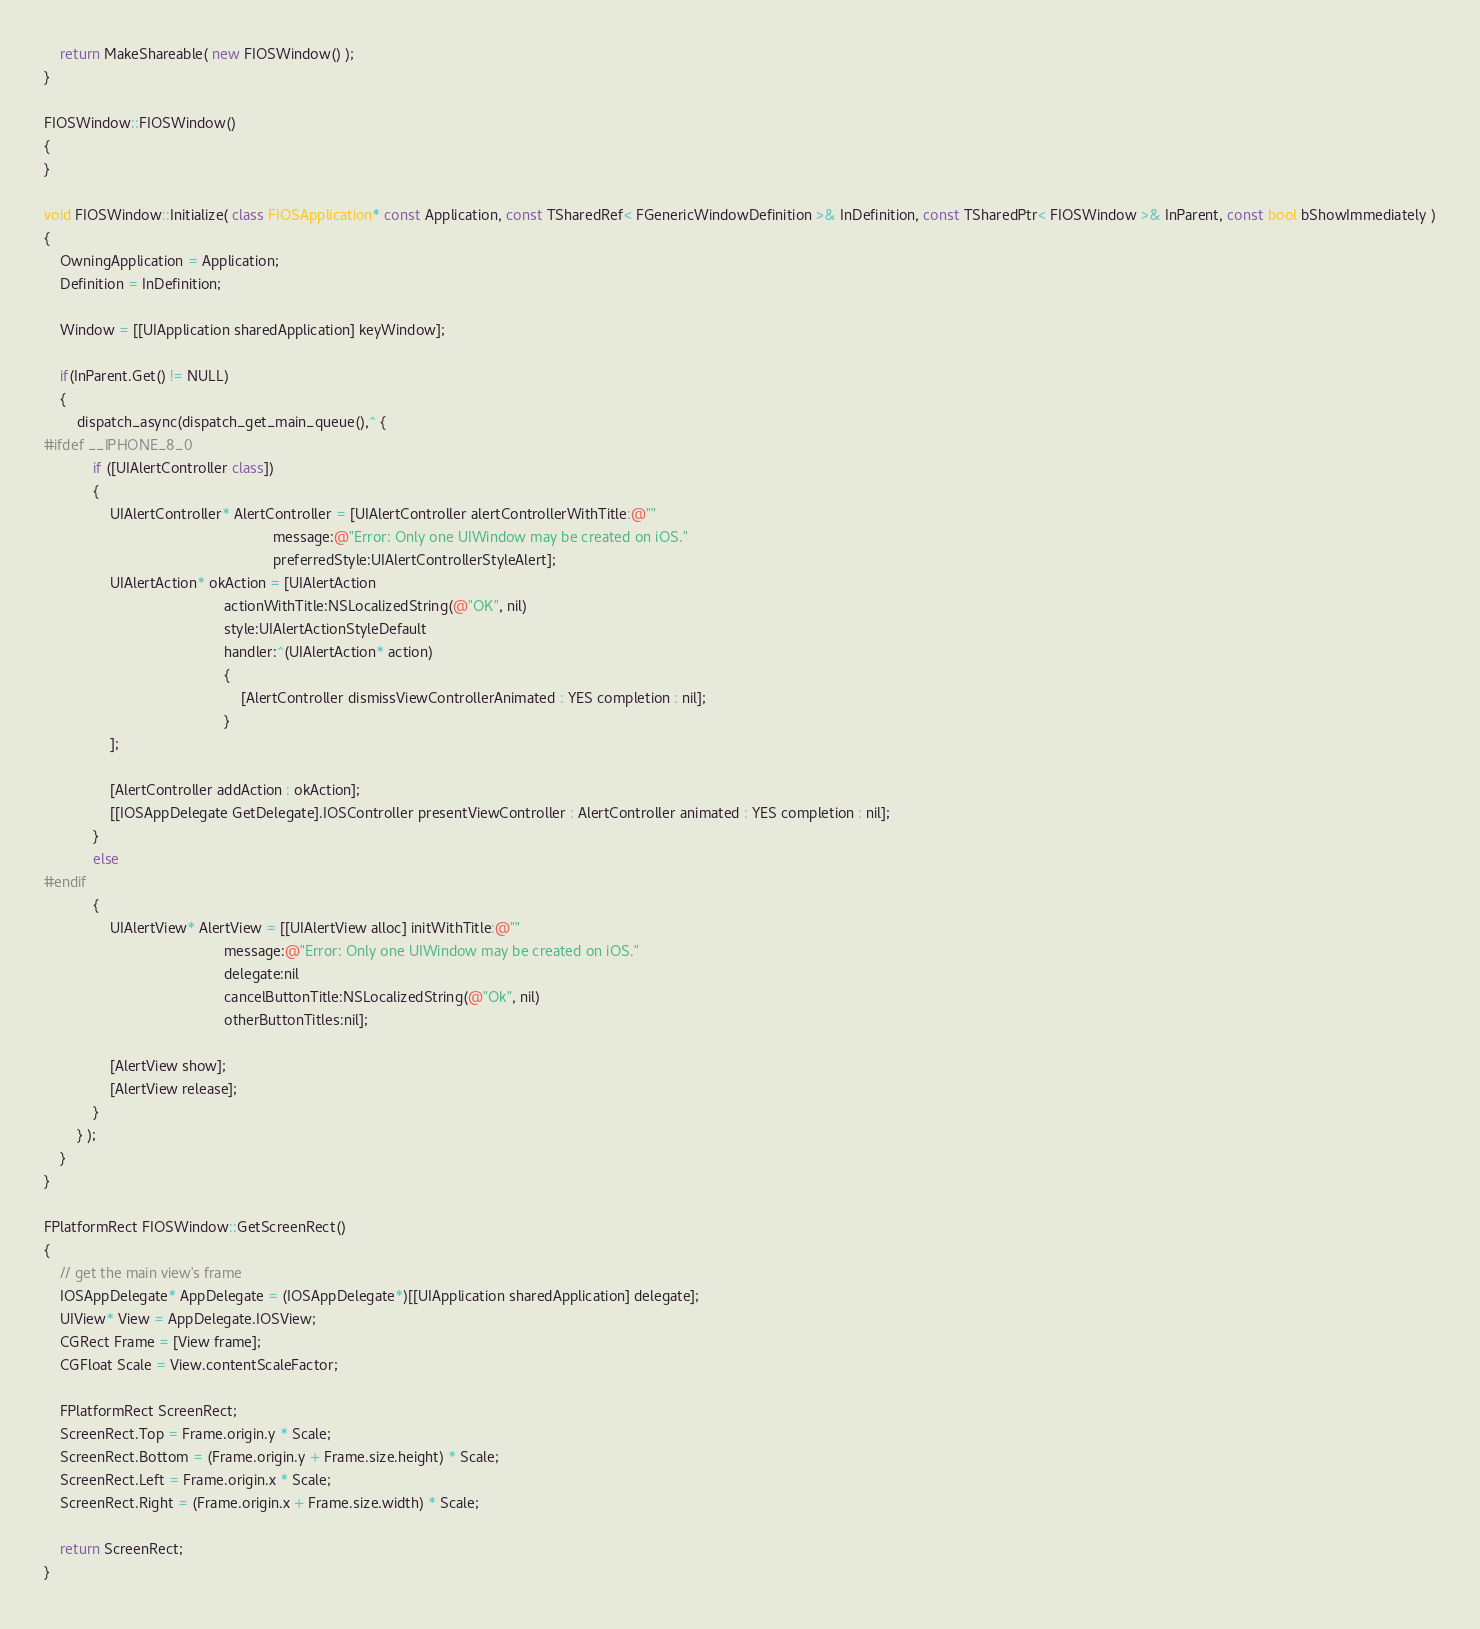<code> <loc_0><loc_0><loc_500><loc_500><_C++_>	return MakeShareable( new FIOSWindow() );
}

FIOSWindow::FIOSWindow()
{
}

void FIOSWindow::Initialize( class FIOSApplication* const Application, const TSharedRef< FGenericWindowDefinition >& InDefinition, const TSharedPtr< FIOSWindow >& InParent, const bool bShowImmediately )
{
	OwningApplication = Application;
	Definition = InDefinition;

	Window = [[UIApplication sharedApplication] keyWindow];

	if(InParent.Get() != NULL)
	{
		dispatch_async(dispatch_get_main_queue(),^ {
#ifdef __IPHONE_8_0
			if ([UIAlertController class])
			{
				UIAlertController* AlertController = [UIAlertController alertControllerWithTitle:@""
														message:@"Error: Only one UIWindow may be created on iOS."
														preferredStyle:UIAlertControllerStyleAlert];
				UIAlertAction* okAction = [UIAlertAction
											actionWithTitle:NSLocalizedString(@"OK", nil)
											style:UIAlertActionStyleDefault
											handler:^(UIAlertAction* action)
											{
												[AlertController dismissViewControllerAnimated : YES completion : nil];
											}
				];

				[AlertController addAction : okAction];
				[[IOSAppDelegate GetDelegate].IOSController presentViewController : AlertController animated : YES completion : nil];
			}
			else
#endif
			{
				UIAlertView* AlertView = [[UIAlertView alloc] initWithTitle:@""
											message:@"Error: Only one UIWindow may be created on iOS."
											delegate:nil
											cancelButtonTitle:NSLocalizedString(@"Ok", nil)
											otherButtonTitles:nil];

				[AlertView show];
				[AlertView release];
			}
		} );
	}
}

FPlatformRect FIOSWindow::GetScreenRect()
{
	// get the main view's frame
	IOSAppDelegate* AppDelegate = (IOSAppDelegate*)[[UIApplication sharedApplication] delegate];
	UIView* View = AppDelegate.IOSView;
	CGRect Frame = [View frame];
	CGFloat Scale = View.contentScaleFactor;

	FPlatformRect ScreenRect;
	ScreenRect.Top = Frame.origin.y * Scale;
	ScreenRect.Bottom = (Frame.origin.y + Frame.size.height) * Scale;
	ScreenRect.Left = Frame.origin.x * Scale;
	ScreenRect.Right = (Frame.origin.x + Frame.size.width) * Scale;

	return ScreenRect;
}

</code> 